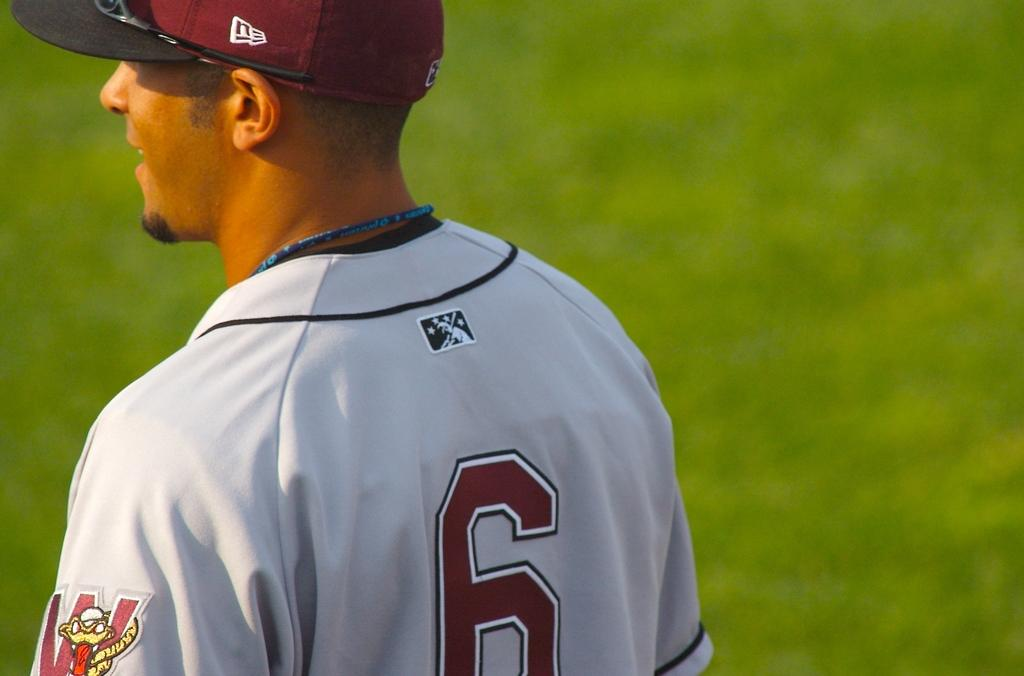<image>
Give a short and clear explanation of the subsequent image. A baseball player in a number 6 jersey is standing on a field. 